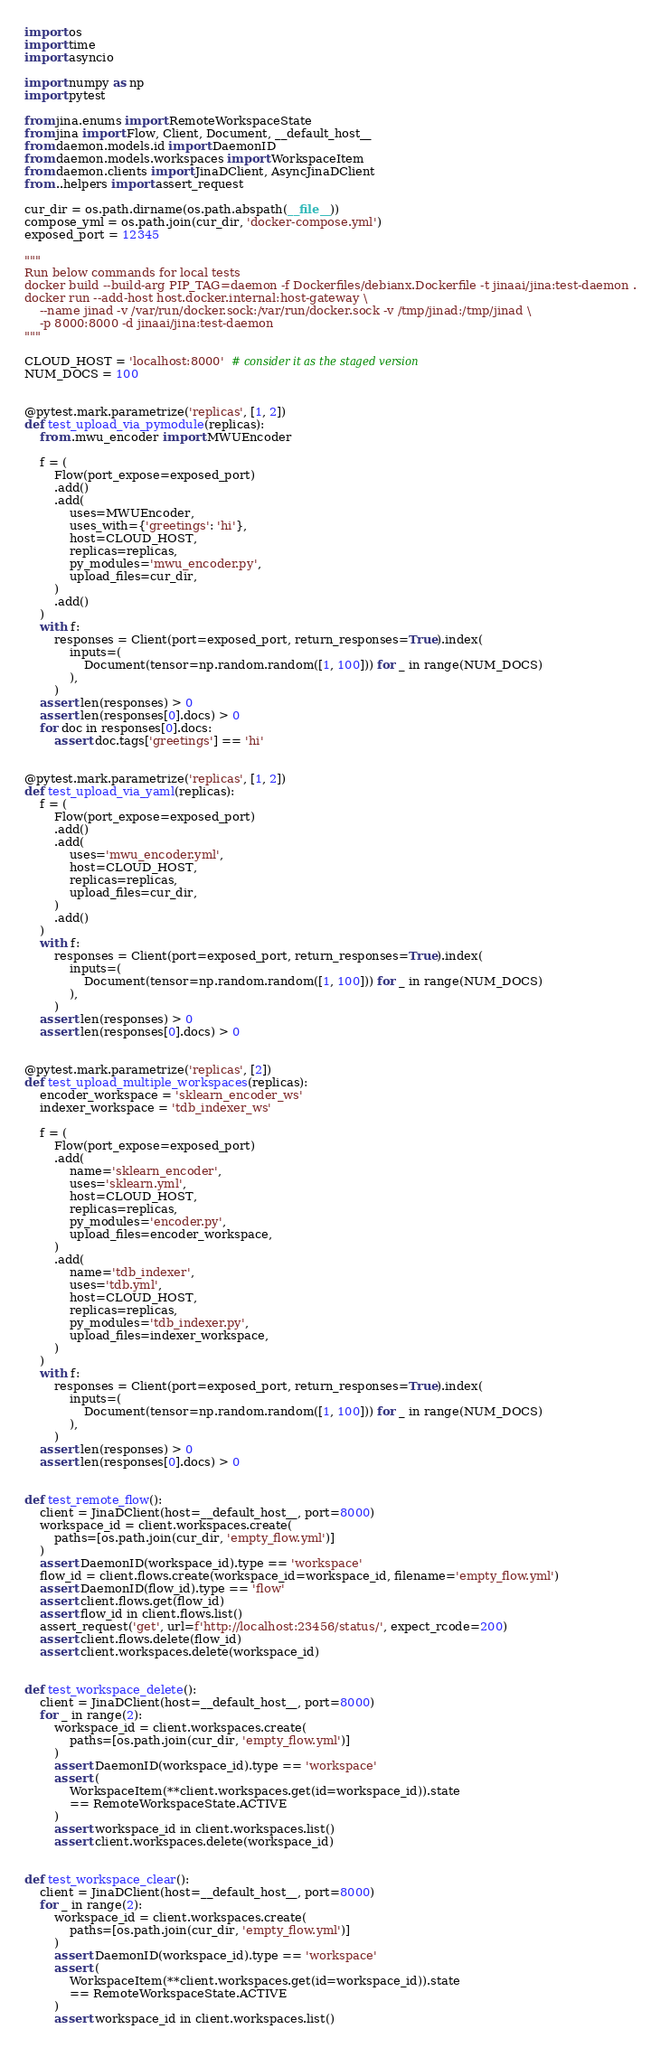<code> <loc_0><loc_0><loc_500><loc_500><_Python_>import os
import time
import asyncio

import numpy as np
import pytest

from jina.enums import RemoteWorkspaceState
from jina import Flow, Client, Document, __default_host__
from daemon.models.id import DaemonID
from daemon.models.workspaces import WorkspaceItem
from daemon.clients import JinaDClient, AsyncJinaDClient
from ..helpers import assert_request

cur_dir = os.path.dirname(os.path.abspath(__file__))
compose_yml = os.path.join(cur_dir, 'docker-compose.yml')
exposed_port = 12345

"""
Run below commands for local tests
docker build --build-arg PIP_TAG=daemon -f Dockerfiles/debianx.Dockerfile -t jinaai/jina:test-daemon .
docker run --add-host host.docker.internal:host-gateway \
    --name jinad -v /var/run/docker.sock:/var/run/docker.sock -v /tmp/jinad:/tmp/jinad \
    -p 8000:8000 -d jinaai/jina:test-daemon
"""

CLOUD_HOST = 'localhost:8000'  # consider it as the staged version
NUM_DOCS = 100


@pytest.mark.parametrize('replicas', [1, 2])
def test_upload_via_pymodule(replicas):
    from .mwu_encoder import MWUEncoder

    f = (
        Flow(port_expose=exposed_port)
        .add()
        .add(
            uses=MWUEncoder,
            uses_with={'greetings': 'hi'},
            host=CLOUD_HOST,
            replicas=replicas,
            py_modules='mwu_encoder.py',
            upload_files=cur_dir,
        )
        .add()
    )
    with f:
        responses = Client(port=exposed_port, return_responses=True).index(
            inputs=(
                Document(tensor=np.random.random([1, 100])) for _ in range(NUM_DOCS)
            ),
        )
    assert len(responses) > 0
    assert len(responses[0].docs) > 0
    for doc in responses[0].docs:
        assert doc.tags['greetings'] == 'hi'


@pytest.mark.parametrize('replicas', [1, 2])
def test_upload_via_yaml(replicas):
    f = (
        Flow(port_expose=exposed_port)
        .add()
        .add(
            uses='mwu_encoder.yml',
            host=CLOUD_HOST,
            replicas=replicas,
            upload_files=cur_dir,
        )
        .add()
    )
    with f:
        responses = Client(port=exposed_port, return_responses=True).index(
            inputs=(
                Document(tensor=np.random.random([1, 100])) for _ in range(NUM_DOCS)
            ),
        )
    assert len(responses) > 0
    assert len(responses[0].docs) > 0


@pytest.mark.parametrize('replicas', [2])
def test_upload_multiple_workspaces(replicas):
    encoder_workspace = 'sklearn_encoder_ws'
    indexer_workspace = 'tdb_indexer_ws'

    f = (
        Flow(port_expose=exposed_port)
        .add(
            name='sklearn_encoder',
            uses='sklearn.yml',
            host=CLOUD_HOST,
            replicas=replicas,
            py_modules='encoder.py',
            upload_files=encoder_workspace,
        )
        .add(
            name='tdb_indexer',
            uses='tdb.yml',
            host=CLOUD_HOST,
            replicas=replicas,
            py_modules='tdb_indexer.py',
            upload_files=indexer_workspace,
        )
    )
    with f:
        responses = Client(port=exposed_port, return_responses=True).index(
            inputs=(
                Document(tensor=np.random.random([1, 100])) for _ in range(NUM_DOCS)
            ),
        )
    assert len(responses) > 0
    assert len(responses[0].docs) > 0


def test_remote_flow():
    client = JinaDClient(host=__default_host__, port=8000)
    workspace_id = client.workspaces.create(
        paths=[os.path.join(cur_dir, 'empty_flow.yml')]
    )
    assert DaemonID(workspace_id).type == 'workspace'
    flow_id = client.flows.create(workspace_id=workspace_id, filename='empty_flow.yml')
    assert DaemonID(flow_id).type == 'flow'
    assert client.flows.get(flow_id)
    assert flow_id in client.flows.list()
    assert_request('get', url=f'http://localhost:23456/status/', expect_rcode=200)
    assert client.flows.delete(flow_id)
    assert client.workspaces.delete(workspace_id)


def test_workspace_delete():
    client = JinaDClient(host=__default_host__, port=8000)
    for _ in range(2):
        workspace_id = client.workspaces.create(
            paths=[os.path.join(cur_dir, 'empty_flow.yml')]
        )
        assert DaemonID(workspace_id).type == 'workspace'
        assert (
            WorkspaceItem(**client.workspaces.get(id=workspace_id)).state
            == RemoteWorkspaceState.ACTIVE
        )
        assert workspace_id in client.workspaces.list()
        assert client.workspaces.delete(workspace_id)


def test_workspace_clear():
    client = JinaDClient(host=__default_host__, port=8000)
    for _ in range(2):
        workspace_id = client.workspaces.create(
            paths=[os.path.join(cur_dir, 'empty_flow.yml')]
        )
        assert DaemonID(workspace_id).type == 'workspace'
        assert (
            WorkspaceItem(**client.workspaces.get(id=workspace_id)).state
            == RemoteWorkspaceState.ACTIVE
        )
        assert workspace_id in client.workspaces.list()</code> 